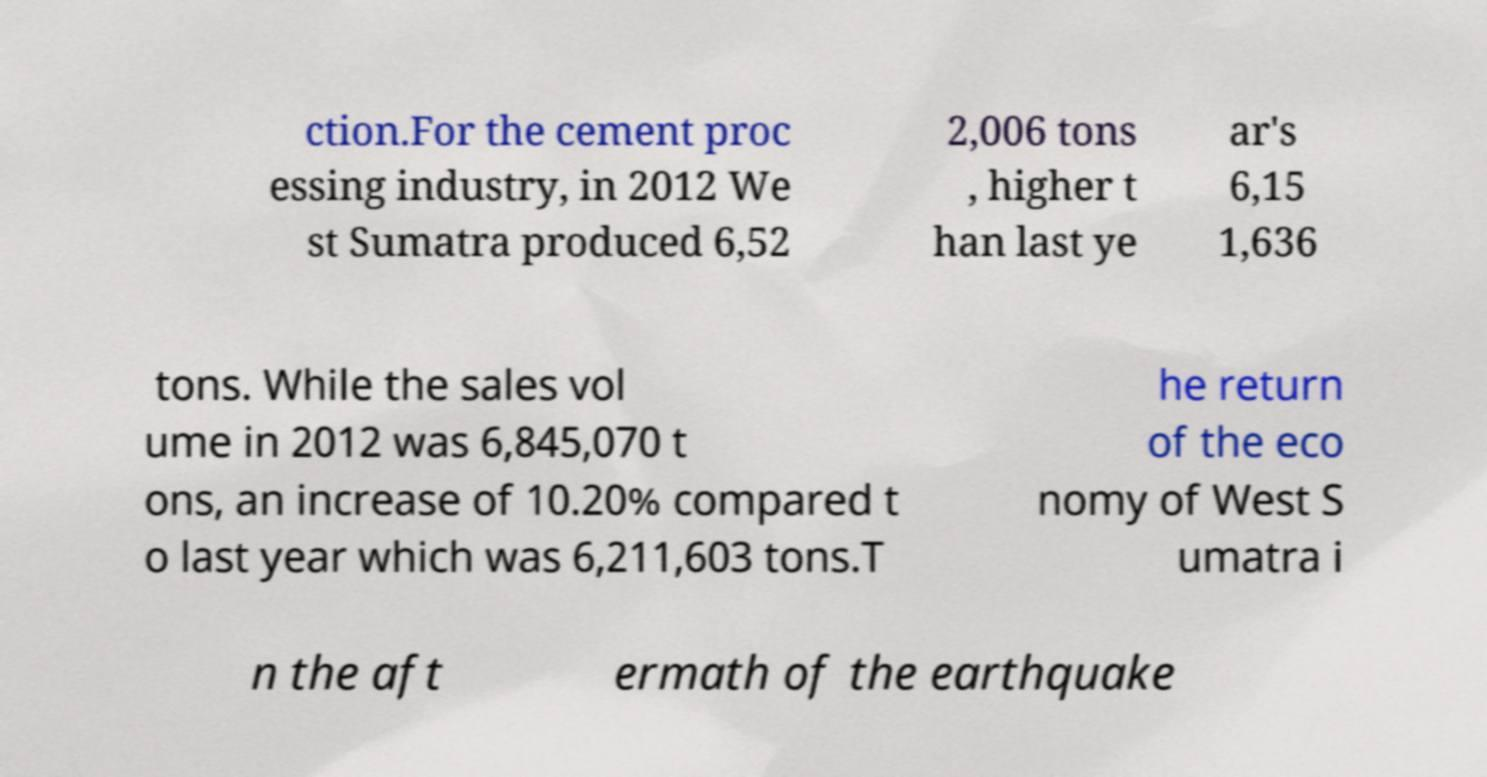I need the written content from this picture converted into text. Can you do that? ction.For the cement proc essing industry, in 2012 We st Sumatra produced 6,52 2,006 tons , higher t han last ye ar's 6,15 1,636 tons. While the sales vol ume in 2012 was 6,845,070 t ons, an increase of 10.20% compared t o last year which was 6,211,603 tons.T he return of the eco nomy of West S umatra i n the aft ermath of the earthquake 